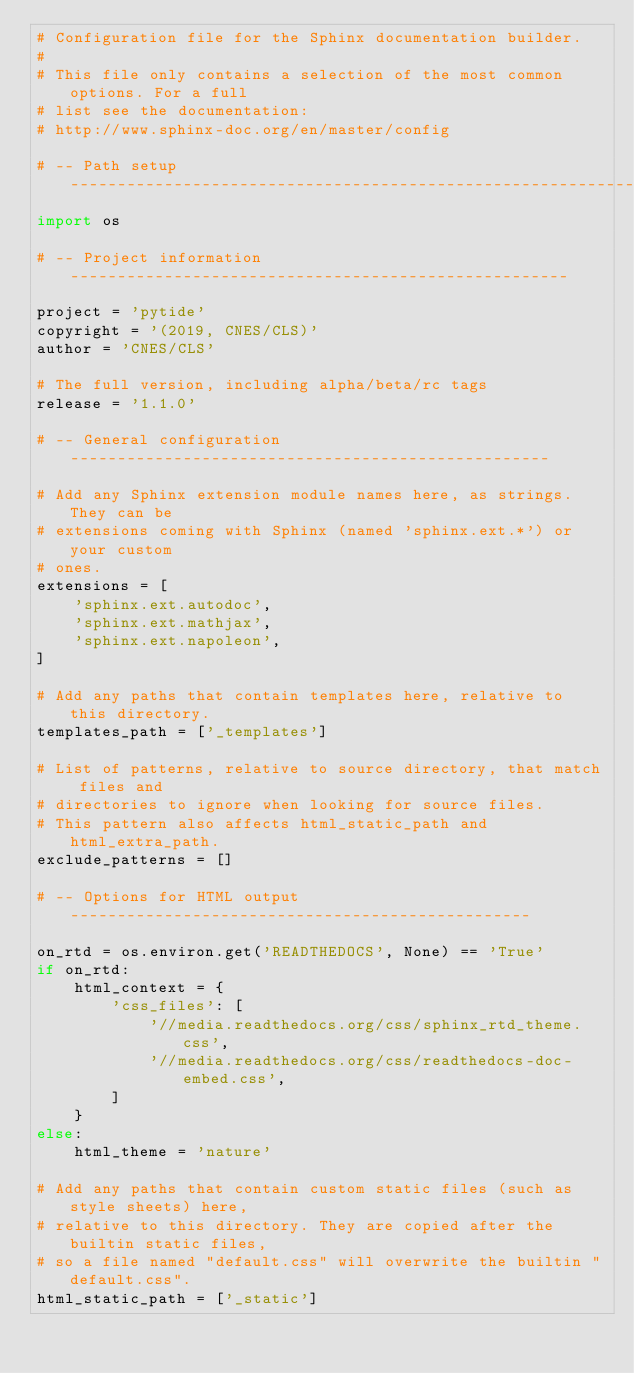<code> <loc_0><loc_0><loc_500><loc_500><_Python_># Configuration file for the Sphinx documentation builder.
#
# This file only contains a selection of the most common options. For a full
# list see the documentation:
# http://www.sphinx-doc.org/en/master/config

# -- Path setup --------------------------------------------------------------
import os

# -- Project information -----------------------------------------------------

project = 'pytide'
copyright = '(2019, CNES/CLS)'
author = 'CNES/CLS'

# The full version, including alpha/beta/rc tags
release = '1.1.0'

# -- General configuration ---------------------------------------------------

# Add any Sphinx extension module names here, as strings. They can be
# extensions coming with Sphinx (named 'sphinx.ext.*') or your custom
# ones.
extensions = [
    'sphinx.ext.autodoc',
    'sphinx.ext.mathjax',
    'sphinx.ext.napoleon',
]

# Add any paths that contain templates here, relative to this directory.
templates_path = ['_templates']

# List of patterns, relative to source directory, that match files and
# directories to ignore when looking for source files.
# This pattern also affects html_static_path and html_extra_path.
exclude_patterns = []

# -- Options for HTML output -------------------------------------------------

on_rtd = os.environ.get('READTHEDOCS', None) == 'True'
if on_rtd:
    html_context = {
        'css_files': [
            '//media.readthedocs.org/css/sphinx_rtd_theme.css',
            '//media.readthedocs.org/css/readthedocs-doc-embed.css',
        ]
    }
else:
    html_theme = 'nature'

# Add any paths that contain custom static files (such as style sheets) here,
# relative to this directory. They are copied after the builtin static files,
# so a file named "default.css" will overwrite the builtin "default.css".
html_static_path = ['_static']
</code> 